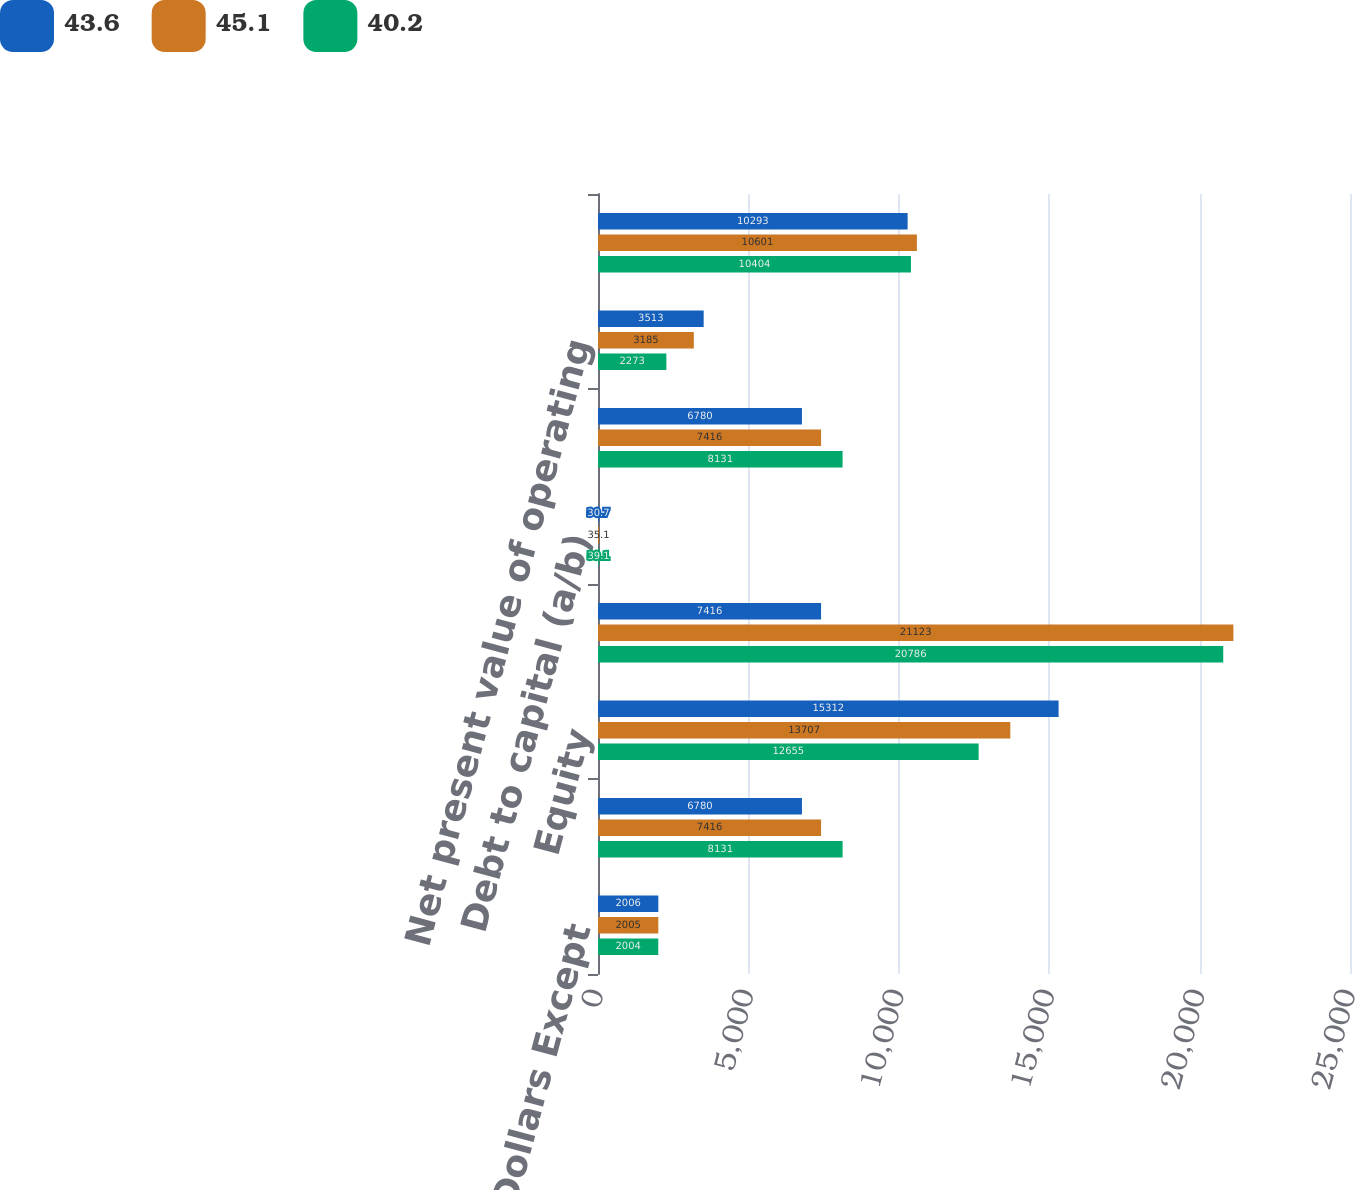<chart> <loc_0><loc_0><loc_500><loc_500><stacked_bar_chart><ecel><fcel>Millions of Dollars Except<fcel>Debt (a)<fcel>Equity<fcel>Capital (b)<fcel>Debt to capital (a/b)<fcel>Debt<fcel>Net present value of operating<fcel>Lease adjusted debt (a)<nl><fcel>43.6<fcel>2006<fcel>6780<fcel>15312<fcel>7416<fcel>30.7<fcel>6780<fcel>3513<fcel>10293<nl><fcel>45.1<fcel>2005<fcel>7416<fcel>13707<fcel>21123<fcel>35.1<fcel>7416<fcel>3185<fcel>10601<nl><fcel>40.2<fcel>2004<fcel>8131<fcel>12655<fcel>20786<fcel>39.1<fcel>8131<fcel>2273<fcel>10404<nl></chart> 